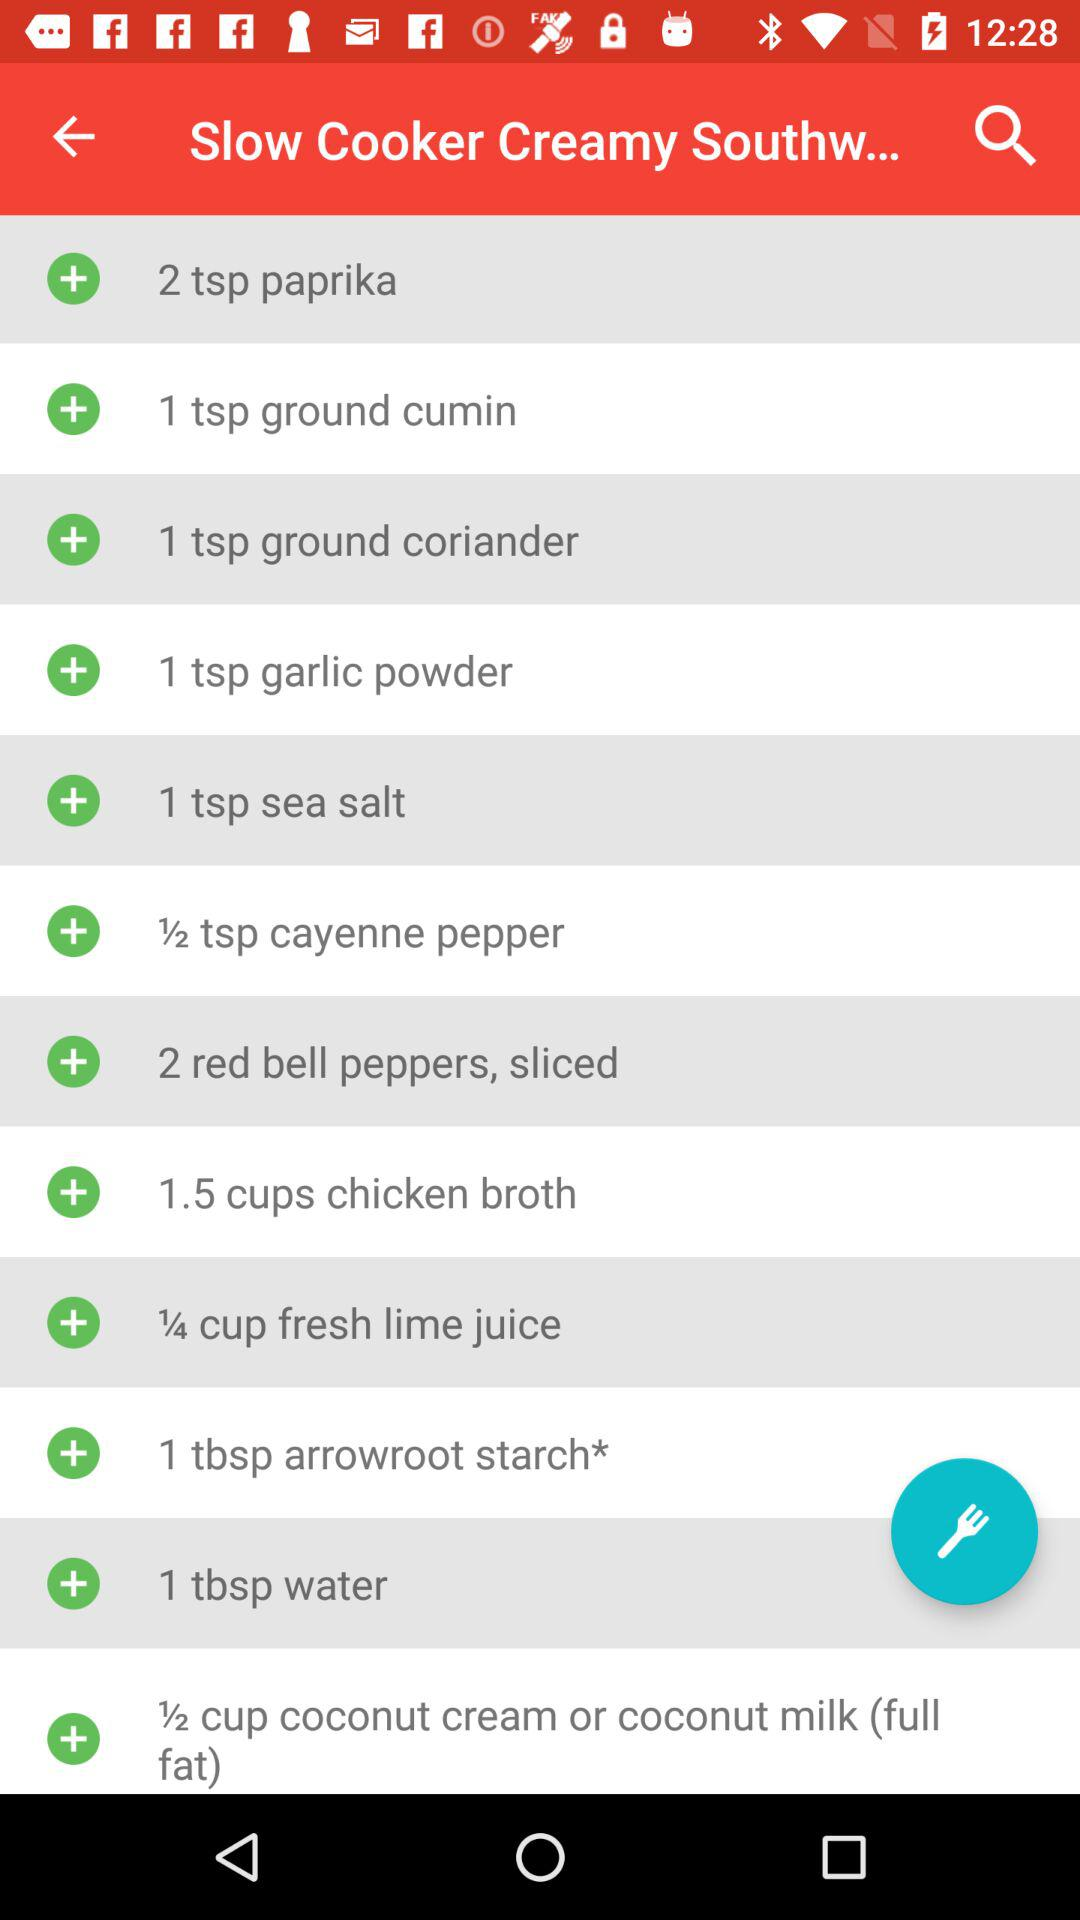How much paprika is required? The amount of paprika required is 2 teaspoon. 